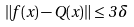<formula> <loc_0><loc_0><loc_500><loc_500>\| f ( x ) - Q ( x ) \| \leq 3 \, \delta</formula> 